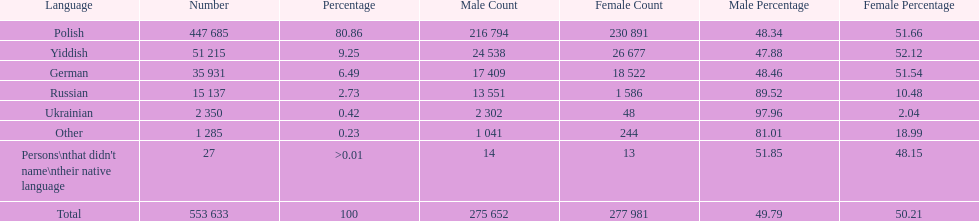How many people didn't name their native language? 27. 